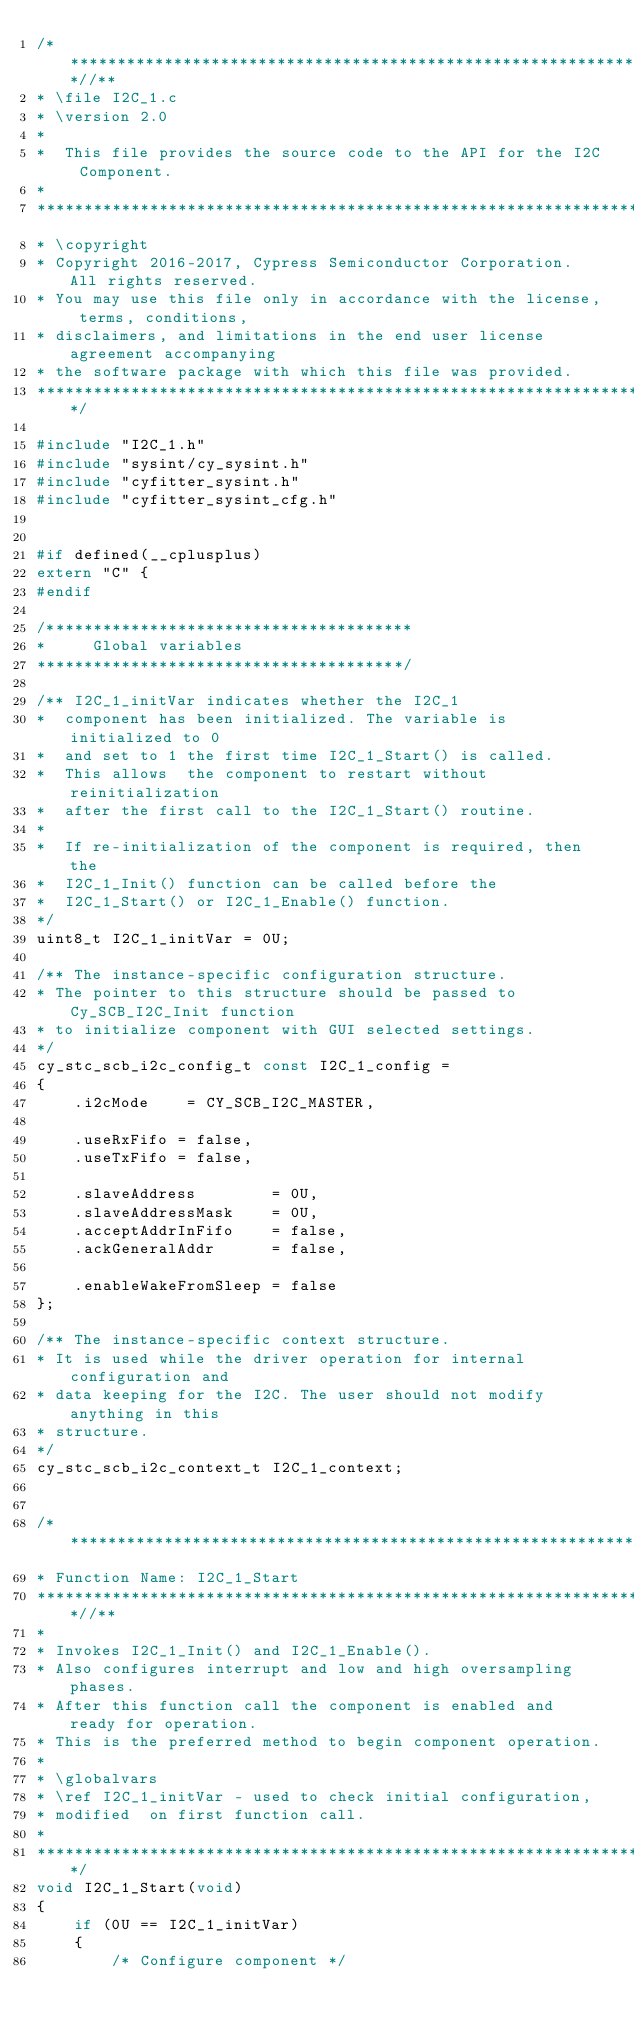<code> <loc_0><loc_0><loc_500><loc_500><_C_>/***************************************************************************//**
* \file I2C_1.c
* \version 2.0
*
*  This file provides the source code to the API for the I2C Component.
*
********************************************************************************
* \copyright
* Copyright 2016-2017, Cypress Semiconductor Corporation. All rights reserved.
* You may use this file only in accordance with the license, terms, conditions,
* disclaimers, and limitations in the end user license agreement accompanying
* the software package with which this file was provided.
*******************************************************************************/

#include "I2C_1.h"
#include "sysint/cy_sysint.h"
#include "cyfitter_sysint.h"
#include "cyfitter_sysint_cfg.h"


#if defined(__cplusplus)
extern "C" {
#endif

/***************************************
*     Global variables
***************************************/

/** I2C_1_initVar indicates whether the I2C_1
*  component has been initialized. The variable is initialized to 0
*  and set to 1 the first time I2C_1_Start() is called.
*  This allows  the component to restart without reinitialization
*  after the first call to the I2C_1_Start() routine.
*
*  If re-initialization of the component is required, then the
*  I2C_1_Init() function can be called before the
*  I2C_1_Start() or I2C_1_Enable() function.
*/
uint8_t I2C_1_initVar = 0U;

/** The instance-specific configuration structure.
* The pointer to this structure should be passed to Cy_SCB_I2C_Init function
* to initialize component with GUI selected settings.
*/
cy_stc_scb_i2c_config_t const I2C_1_config =
{
    .i2cMode    = CY_SCB_I2C_MASTER,

    .useRxFifo = false,
    .useTxFifo = false,

    .slaveAddress        = 0U,
    .slaveAddressMask    = 0U,
    .acceptAddrInFifo    = false,
    .ackGeneralAddr      = false,

    .enableWakeFromSleep = false
};

/** The instance-specific context structure.
* It is used while the driver operation for internal configuration and
* data keeping for the I2C. The user should not modify anything in this
* structure.
*/
cy_stc_scb_i2c_context_t I2C_1_context;


/*******************************************************************************
* Function Name: I2C_1_Start
****************************************************************************//**
*
* Invokes I2C_1_Init() and I2C_1_Enable().
* Also configures interrupt and low and high oversampling phases.
* After this function call the component is enabled and ready for operation.
* This is the preferred method to begin component operation.
*
* \globalvars
* \ref I2C_1_initVar - used to check initial configuration,
* modified  on first function call.
*
*******************************************************************************/
void I2C_1_Start(void)
{
    if (0U == I2C_1_initVar)
    {
        /* Configure component */</code> 